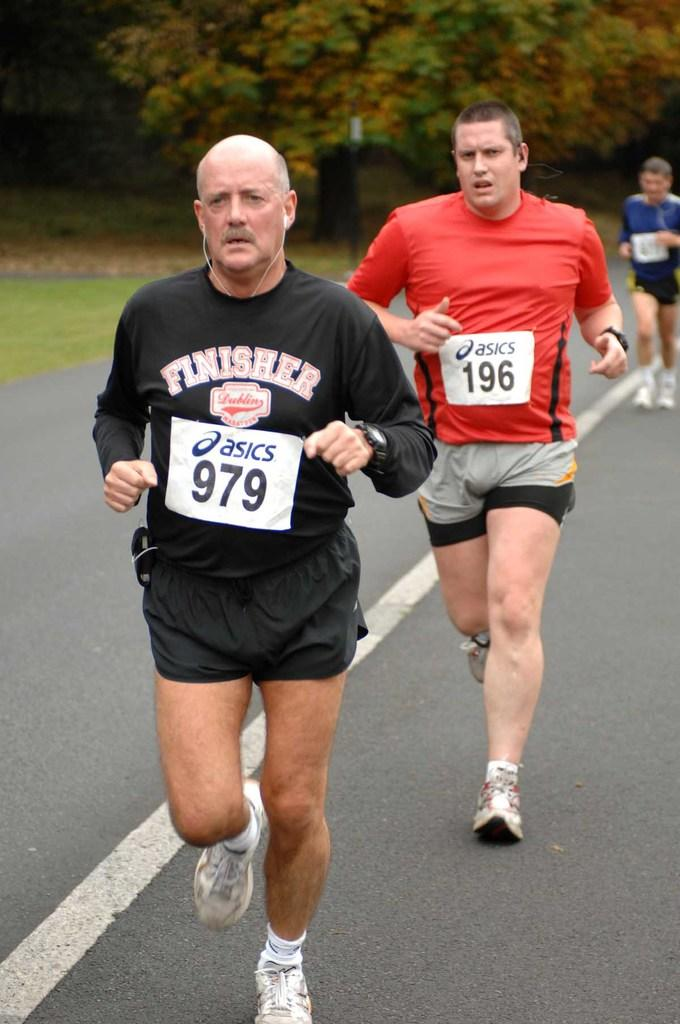How many people are in the image? There are three persons in the image. What are the persons doing in the image? The persons are running on the road. What can be seen in the background of the image? There is grass and trees in the background of the image. What type of pleasure can be seen in the image? There is no specific pleasure depicted in the image; it shows three persons running on the road. What type of voyage are the persons taking in the image? There is no voyage depicted in the image; it shows three persons running on the road. 